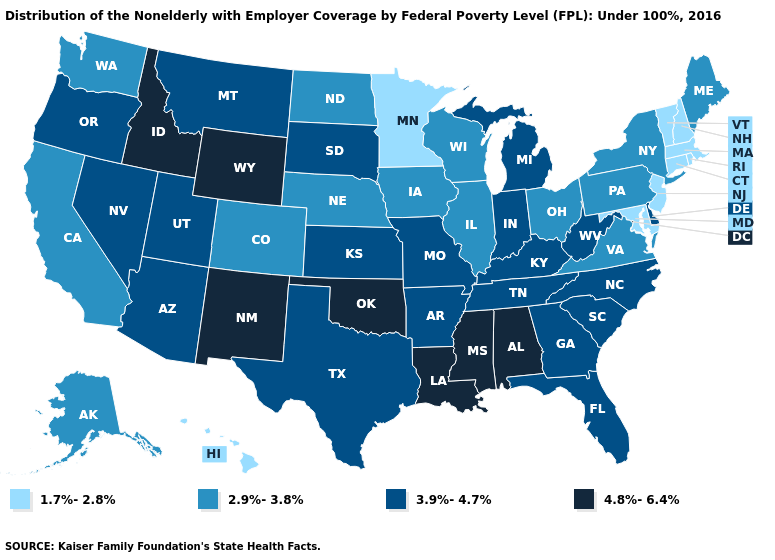What is the lowest value in the USA?
Quick response, please. 1.7%-2.8%. What is the value of Hawaii?
Keep it brief. 1.7%-2.8%. Name the states that have a value in the range 1.7%-2.8%?
Keep it brief. Connecticut, Hawaii, Maryland, Massachusetts, Minnesota, New Hampshire, New Jersey, Rhode Island, Vermont. Name the states that have a value in the range 4.8%-6.4%?
Answer briefly. Alabama, Idaho, Louisiana, Mississippi, New Mexico, Oklahoma, Wyoming. What is the highest value in the Northeast ?
Answer briefly. 2.9%-3.8%. What is the value of Illinois?
Write a very short answer. 2.9%-3.8%. What is the lowest value in the USA?
Give a very brief answer. 1.7%-2.8%. Among the states that border West Virginia , does Ohio have the lowest value?
Keep it brief. No. What is the highest value in the USA?
Answer briefly. 4.8%-6.4%. Does Alabama have the highest value in the South?
Quick response, please. Yes. Does Virginia have a lower value than Indiana?
Write a very short answer. Yes. Among the states that border Vermont , does New Hampshire have the lowest value?
Give a very brief answer. Yes. What is the lowest value in the Northeast?
Short answer required. 1.7%-2.8%. What is the value of Texas?
Concise answer only. 3.9%-4.7%. Which states have the lowest value in the USA?
Concise answer only. Connecticut, Hawaii, Maryland, Massachusetts, Minnesota, New Hampshire, New Jersey, Rhode Island, Vermont. 